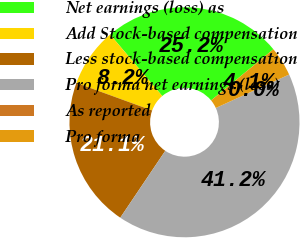Convert chart to OTSL. <chart><loc_0><loc_0><loc_500><loc_500><pie_chart><fcel>Net earnings (loss) as<fcel>Add Stock-based compensation<fcel>Less stock-based compensation<fcel>Pro forma net earnings (loss)<fcel>As reported<fcel>Pro forma<nl><fcel>25.25%<fcel>8.25%<fcel>21.13%<fcel>41.23%<fcel>0.01%<fcel>4.13%<nl></chart> 